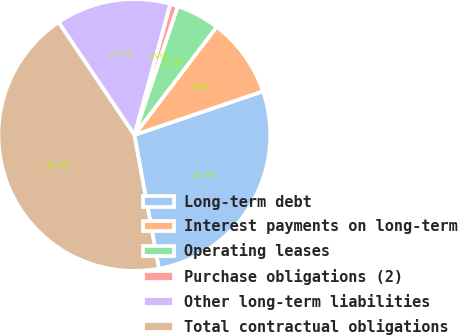Convert chart. <chart><loc_0><loc_0><loc_500><loc_500><pie_chart><fcel>Long-term debt<fcel>Interest payments on long-term<fcel>Operating leases<fcel>Purchase obligations (2)<fcel>Other long-term liabilities<fcel>Total contractual obligations<nl><fcel>27.32%<fcel>9.43%<fcel>5.18%<fcel>0.92%<fcel>13.68%<fcel>43.47%<nl></chart> 